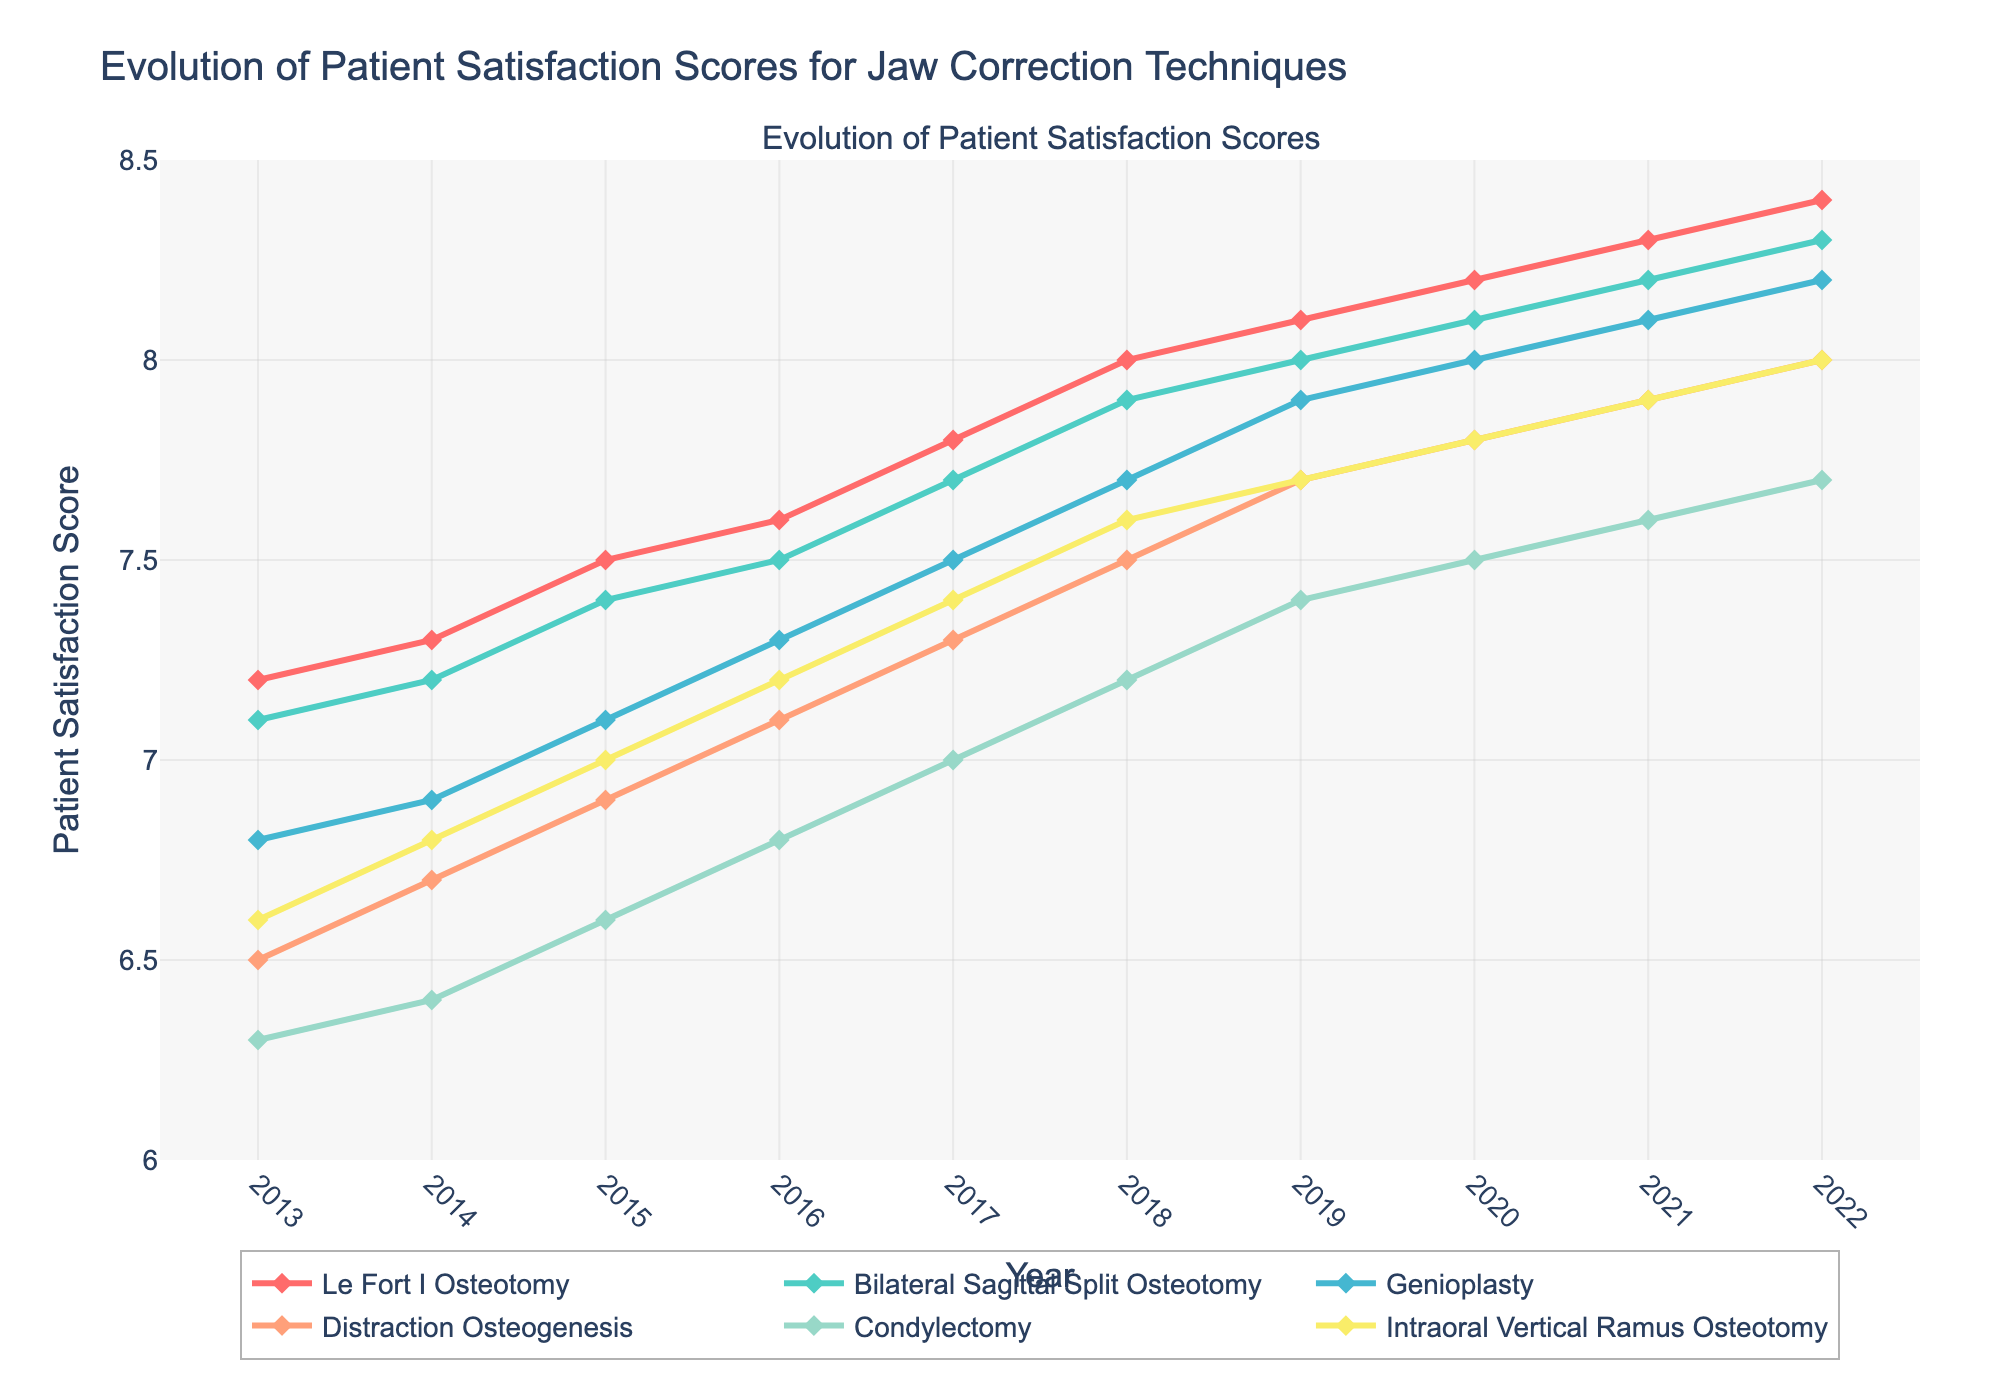Which technique showed the highest patient satisfaction score in 2022? Examine the patient satisfaction scores for all techniques in 2022 and identify the highest one.
Answer: Le Fort I Osteotomy Which technique experienced the greatest overall increase in satisfaction score from 2013 to 2022? Calculate the difference between 2022 and 2013 satisfaction scores for each technique and find the maximum. Le Fort I Osteotomy increased by 1.2, Bilateral Sagittal Split Osteotomy by 1.2, Genioplasty by 1.4, Distraction Osteogenesis by 1.5, Condylectomy by 1.4, Intraoral Vertical Ramus Osteotomy by 1.4
Answer: Distraction Osteogenesis What is the average patient satisfaction score for Genioplasty over the entire decade? Sum the annual scores for Genioplasty from 2013 to 2022 and divide by the number of years: (6.8 + 6.9 + 7.1 + 7.3 + 7.5 + 7.7 + 7.9 + 8.0 + 8.1 + 8.2) / 10.
Answer: 7.55 Compare the satisfaction score trends between Le Fort I Osteotomy and Condylectomy. Which one shows a steeper increase? Calculate the difference between 2013 and 2022 for both techniques: Le Fort I Osteotomy increased by 1.2 and Condylectomy increased by 1.4.
Answer: Condylectomy Which year showed the highest overall patient satisfaction score for all techniques? Identify the highest satisfaction score year for each technique and find the common year if there is one; otherwise, the answer would be the highest individual score year. All highest scores were in 2022.
Answer: 2022 Between 2019 and 2020, which technique had the smallest improvement in satisfaction score? Calculate the difference between 2019 and 2020 for each technique: Le Fort I Osteotomy by 0.1, Bilateral Sagittal Split Osteotomy by 0.1, Genioplasty by 0.1, Distraction Osteogenesis by 0.1, Condylectomy by 0.1, Intraoral Vertical Ramus Osteotomy by 0.1. The smallest possible improvement is 0.1.
Answer: All techniques had the same smallest improvement of 0.1 Out of Genioplasty and Distraction Osteogenesis, which method had a higher satisfaction score in 2016? Compare satisfaction scores in 2016 for Genioplasty (7.3) and Distraction Osteogenesis (7.1).
Answer: Genioplasty How much did the satisfaction score increase for Intraoral Vertical Ramus Osteotomy from 2013 to 2015? Subtract the 2013 satisfaction score from the 2015 score for Intraoral Vertical Ramus Osteotomy: 7.0 - 6.6 = 0.4.
Answer: 0.4 Which technique showed the most consistent increase in satisfaction scores over the decade? Look for the technique with the most uniform increase year-over-year. All techniques showed similar increases each year, but Le Fort I Osteotomy has a very smooth and consistent rise.
Answer: Le Fort I Osteotomy 